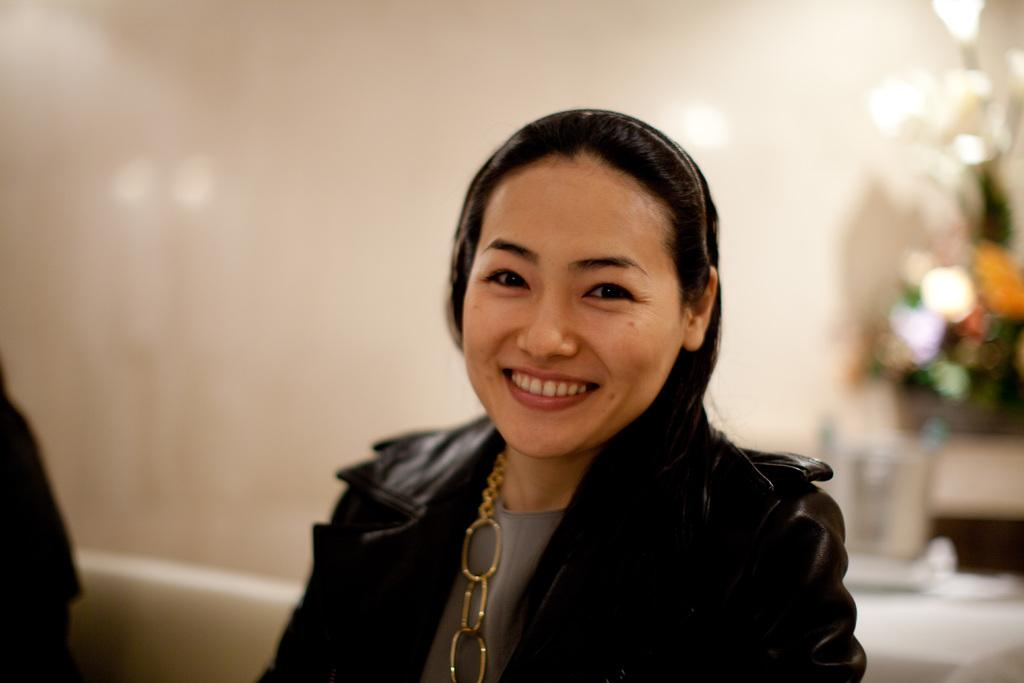What is the expression of the person in the image? The person in the image has a smile on her face. Who is beside the person with the smile? There is another person beside her. What can be seen behind the person with the smile? There is a flower pot behind her. What is the background of the image made up of? There is a wall in the image, and lights are visible. What type of cord is being used to hold the meeting in the image? There is no meeting or cord present in the image. Is there a net visible in the image? No, there is no net visible in the image. 